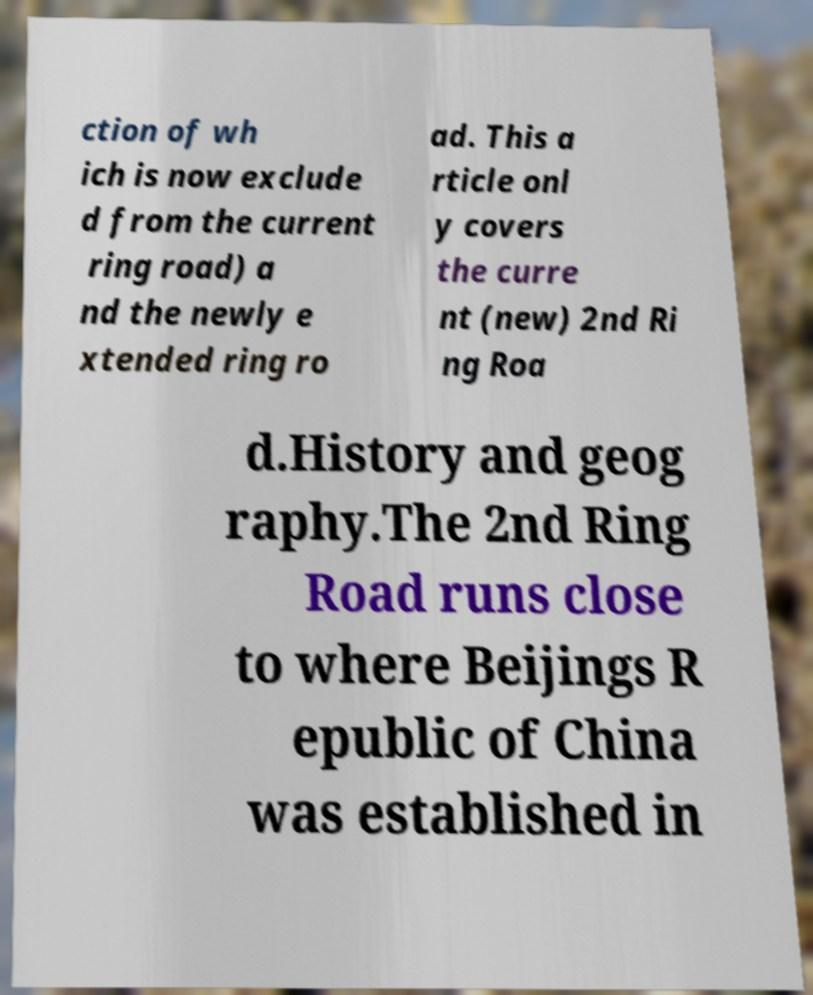For documentation purposes, I need the text within this image transcribed. Could you provide that? ction of wh ich is now exclude d from the current ring road) a nd the newly e xtended ring ro ad. This a rticle onl y covers the curre nt (new) 2nd Ri ng Roa d.History and geog raphy.The 2nd Ring Road runs close to where Beijings R epublic of China was established in 